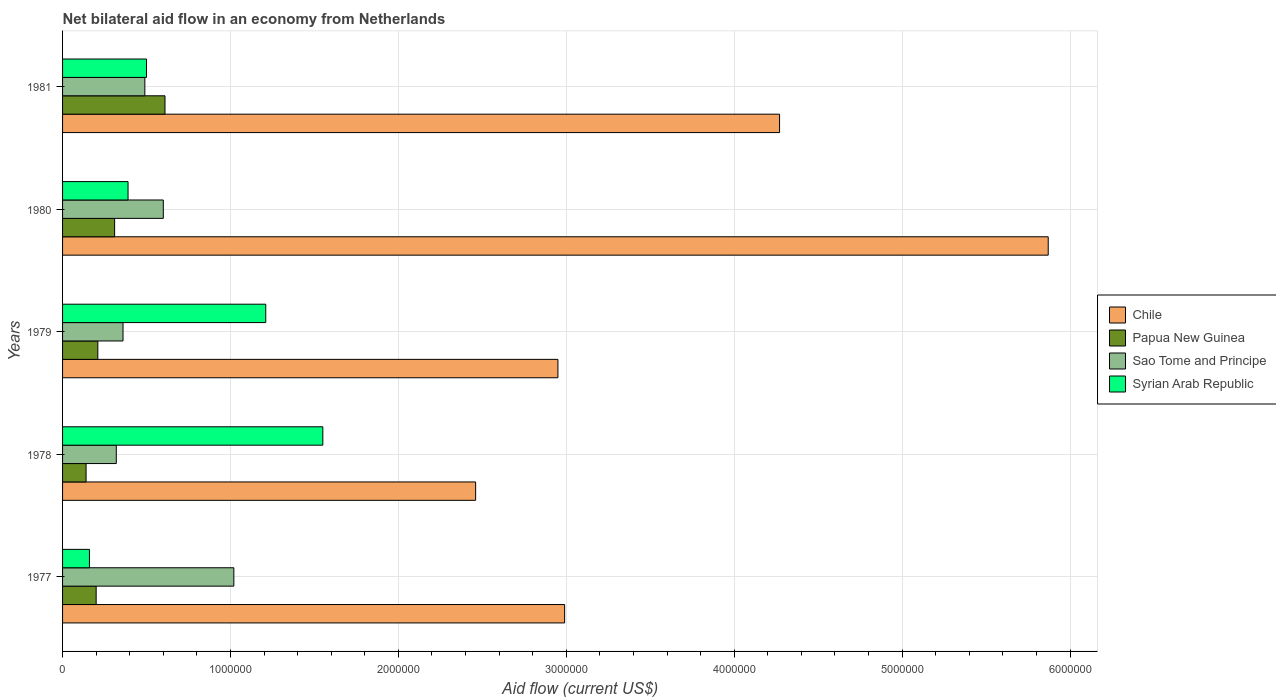Are the number of bars per tick equal to the number of legend labels?
Give a very brief answer. Yes. How many bars are there on the 2nd tick from the top?
Make the answer very short. 4. How many bars are there on the 4th tick from the bottom?
Your answer should be compact. 4. What is the label of the 3rd group of bars from the top?
Provide a short and direct response. 1979. In how many cases, is the number of bars for a given year not equal to the number of legend labels?
Your answer should be very brief. 0. Across all years, what is the maximum net bilateral aid flow in Sao Tome and Principe?
Provide a succinct answer. 1.02e+06. Across all years, what is the minimum net bilateral aid flow in Papua New Guinea?
Give a very brief answer. 1.40e+05. What is the total net bilateral aid flow in Chile in the graph?
Make the answer very short. 1.85e+07. What is the difference between the net bilateral aid flow in Sao Tome and Principe in 1979 and that in 1980?
Make the answer very short. -2.40e+05. What is the difference between the net bilateral aid flow in Syrian Arab Republic in 1981 and the net bilateral aid flow in Chile in 1977?
Your answer should be compact. -2.49e+06. What is the average net bilateral aid flow in Chile per year?
Provide a succinct answer. 3.71e+06. In the year 1979, what is the difference between the net bilateral aid flow in Syrian Arab Republic and net bilateral aid flow in Chile?
Provide a short and direct response. -1.74e+06. In how many years, is the net bilateral aid flow in Chile greater than 4000000 US$?
Your response must be concise. 2. What is the ratio of the net bilateral aid flow in Papua New Guinea in 1977 to that in 1978?
Offer a very short reply. 1.43. What is the difference between the highest and the lowest net bilateral aid flow in Syrian Arab Republic?
Provide a succinct answer. 1.39e+06. In how many years, is the net bilateral aid flow in Chile greater than the average net bilateral aid flow in Chile taken over all years?
Your response must be concise. 2. Is the sum of the net bilateral aid flow in Chile in 1977 and 1979 greater than the maximum net bilateral aid flow in Sao Tome and Principe across all years?
Offer a terse response. Yes. Is it the case that in every year, the sum of the net bilateral aid flow in Syrian Arab Republic and net bilateral aid flow in Chile is greater than the sum of net bilateral aid flow in Papua New Guinea and net bilateral aid flow in Sao Tome and Principe?
Provide a short and direct response. No. What does the 2nd bar from the top in 1977 represents?
Offer a very short reply. Sao Tome and Principe. What does the 2nd bar from the bottom in 1980 represents?
Provide a short and direct response. Papua New Guinea. How many bars are there?
Ensure brevity in your answer.  20. How many legend labels are there?
Provide a succinct answer. 4. What is the title of the graph?
Provide a short and direct response. Net bilateral aid flow in an economy from Netherlands. Does "United States" appear as one of the legend labels in the graph?
Provide a short and direct response. No. What is the label or title of the Y-axis?
Make the answer very short. Years. What is the Aid flow (current US$) of Chile in 1977?
Make the answer very short. 2.99e+06. What is the Aid flow (current US$) in Papua New Guinea in 1977?
Give a very brief answer. 2.00e+05. What is the Aid flow (current US$) of Sao Tome and Principe in 1977?
Give a very brief answer. 1.02e+06. What is the Aid flow (current US$) of Syrian Arab Republic in 1977?
Offer a terse response. 1.60e+05. What is the Aid flow (current US$) in Chile in 1978?
Provide a short and direct response. 2.46e+06. What is the Aid flow (current US$) of Papua New Guinea in 1978?
Give a very brief answer. 1.40e+05. What is the Aid flow (current US$) of Syrian Arab Republic in 1978?
Your response must be concise. 1.55e+06. What is the Aid flow (current US$) in Chile in 1979?
Provide a short and direct response. 2.95e+06. What is the Aid flow (current US$) of Syrian Arab Republic in 1979?
Keep it short and to the point. 1.21e+06. What is the Aid flow (current US$) in Chile in 1980?
Offer a terse response. 5.87e+06. What is the Aid flow (current US$) in Sao Tome and Principe in 1980?
Give a very brief answer. 6.00e+05. What is the Aid flow (current US$) in Syrian Arab Republic in 1980?
Offer a terse response. 3.90e+05. What is the Aid flow (current US$) in Chile in 1981?
Keep it short and to the point. 4.27e+06. What is the Aid flow (current US$) of Papua New Guinea in 1981?
Make the answer very short. 6.10e+05. Across all years, what is the maximum Aid flow (current US$) of Chile?
Offer a terse response. 5.87e+06. Across all years, what is the maximum Aid flow (current US$) in Sao Tome and Principe?
Your answer should be compact. 1.02e+06. Across all years, what is the maximum Aid flow (current US$) in Syrian Arab Republic?
Make the answer very short. 1.55e+06. Across all years, what is the minimum Aid flow (current US$) in Chile?
Provide a succinct answer. 2.46e+06. What is the total Aid flow (current US$) in Chile in the graph?
Your response must be concise. 1.85e+07. What is the total Aid flow (current US$) of Papua New Guinea in the graph?
Your answer should be very brief. 1.47e+06. What is the total Aid flow (current US$) of Sao Tome and Principe in the graph?
Provide a short and direct response. 2.79e+06. What is the total Aid flow (current US$) in Syrian Arab Republic in the graph?
Offer a terse response. 3.81e+06. What is the difference between the Aid flow (current US$) in Chile in 1977 and that in 1978?
Make the answer very short. 5.30e+05. What is the difference between the Aid flow (current US$) of Papua New Guinea in 1977 and that in 1978?
Provide a short and direct response. 6.00e+04. What is the difference between the Aid flow (current US$) of Sao Tome and Principe in 1977 and that in 1978?
Your answer should be compact. 7.00e+05. What is the difference between the Aid flow (current US$) of Syrian Arab Republic in 1977 and that in 1978?
Keep it short and to the point. -1.39e+06. What is the difference between the Aid flow (current US$) in Syrian Arab Republic in 1977 and that in 1979?
Provide a succinct answer. -1.05e+06. What is the difference between the Aid flow (current US$) of Chile in 1977 and that in 1980?
Ensure brevity in your answer.  -2.88e+06. What is the difference between the Aid flow (current US$) in Sao Tome and Principe in 1977 and that in 1980?
Offer a very short reply. 4.20e+05. What is the difference between the Aid flow (current US$) of Chile in 1977 and that in 1981?
Give a very brief answer. -1.28e+06. What is the difference between the Aid flow (current US$) in Papua New Guinea in 1977 and that in 1981?
Your response must be concise. -4.10e+05. What is the difference between the Aid flow (current US$) of Sao Tome and Principe in 1977 and that in 1981?
Ensure brevity in your answer.  5.30e+05. What is the difference between the Aid flow (current US$) of Chile in 1978 and that in 1979?
Offer a terse response. -4.90e+05. What is the difference between the Aid flow (current US$) in Papua New Guinea in 1978 and that in 1979?
Provide a short and direct response. -7.00e+04. What is the difference between the Aid flow (current US$) of Sao Tome and Principe in 1978 and that in 1979?
Give a very brief answer. -4.00e+04. What is the difference between the Aid flow (current US$) in Chile in 1978 and that in 1980?
Your answer should be very brief. -3.41e+06. What is the difference between the Aid flow (current US$) of Papua New Guinea in 1978 and that in 1980?
Provide a succinct answer. -1.70e+05. What is the difference between the Aid flow (current US$) of Sao Tome and Principe in 1978 and that in 1980?
Ensure brevity in your answer.  -2.80e+05. What is the difference between the Aid flow (current US$) in Syrian Arab Republic in 1978 and that in 1980?
Offer a terse response. 1.16e+06. What is the difference between the Aid flow (current US$) of Chile in 1978 and that in 1981?
Provide a succinct answer. -1.81e+06. What is the difference between the Aid flow (current US$) of Papua New Guinea in 1978 and that in 1981?
Keep it short and to the point. -4.70e+05. What is the difference between the Aid flow (current US$) of Syrian Arab Republic in 1978 and that in 1981?
Your answer should be compact. 1.05e+06. What is the difference between the Aid flow (current US$) in Chile in 1979 and that in 1980?
Offer a terse response. -2.92e+06. What is the difference between the Aid flow (current US$) of Papua New Guinea in 1979 and that in 1980?
Your answer should be very brief. -1.00e+05. What is the difference between the Aid flow (current US$) of Sao Tome and Principe in 1979 and that in 1980?
Your answer should be compact. -2.40e+05. What is the difference between the Aid flow (current US$) in Syrian Arab Republic in 1979 and that in 1980?
Make the answer very short. 8.20e+05. What is the difference between the Aid flow (current US$) of Chile in 1979 and that in 1981?
Your response must be concise. -1.32e+06. What is the difference between the Aid flow (current US$) in Papua New Guinea in 1979 and that in 1981?
Provide a succinct answer. -4.00e+05. What is the difference between the Aid flow (current US$) of Sao Tome and Principe in 1979 and that in 1981?
Your answer should be compact. -1.30e+05. What is the difference between the Aid flow (current US$) in Syrian Arab Republic in 1979 and that in 1981?
Provide a succinct answer. 7.10e+05. What is the difference between the Aid flow (current US$) of Chile in 1980 and that in 1981?
Make the answer very short. 1.60e+06. What is the difference between the Aid flow (current US$) in Chile in 1977 and the Aid flow (current US$) in Papua New Guinea in 1978?
Make the answer very short. 2.85e+06. What is the difference between the Aid flow (current US$) of Chile in 1977 and the Aid flow (current US$) of Sao Tome and Principe in 1978?
Your answer should be very brief. 2.67e+06. What is the difference between the Aid flow (current US$) of Chile in 1977 and the Aid flow (current US$) of Syrian Arab Republic in 1978?
Give a very brief answer. 1.44e+06. What is the difference between the Aid flow (current US$) of Papua New Guinea in 1977 and the Aid flow (current US$) of Syrian Arab Republic in 1978?
Offer a terse response. -1.35e+06. What is the difference between the Aid flow (current US$) of Sao Tome and Principe in 1977 and the Aid flow (current US$) of Syrian Arab Republic in 1978?
Keep it short and to the point. -5.30e+05. What is the difference between the Aid flow (current US$) in Chile in 1977 and the Aid flow (current US$) in Papua New Guinea in 1979?
Ensure brevity in your answer.  2.78e+06. What is the difference between the Aid flow (current US$) of Chile in 1977 and the Aid flow (current US$) of Sao Tome and Principe in 1979?
Give a very brief answer. 2.63e+06. What is the difference between the Aid flow (current US$) in Chile in 1977 and the Aid flow (current US$) in Syrian Arab Republic in 1979?
Make the answer very short. 1.78e+06. What is the difference between the Aid flow (current US$) of Papua New Guinea in 1977 and the Aid flow (current US$) of Sao Tome and Principe in 1979?
Make the answer very short. -1.60e+05. What is the difference between the Aid flow (current US$) of Papua New Guinea in 1977 and the Aid flow (current US$) of Syrian Arab Republic in 1979?
Ensure brevity in your answer.  -1.01e+06. What is the difference between the Aid flow (current US$) of Chile in 1977 and the Aid flow (current US$) of Papua New Guinea in 1980?
Offer a very short reply. 2.68e+06. What is the difference between the Aid flow (current US$) in Chile in 1977 and the Aid flow (current US$) in Sao Tome and Principe in 1980?
Your answer should be very brief. 2.39e+06. What is the difference between the Aid flow (current US$) in Chile in 1977 and the Aid flow (current US$) in Syrian Arab Republic in 1980?
Ensure brevity in your answer.  2.60e+06. What is the difference between the Aid flow (current US$) in Papua New Guinea in 1977 and the Aid flow (current US$) in Sao Tome and Principe in 1980?
Give a very brief answer. -4.00e+05. What is the difference between the Aid flow (current US$) of Papua New Guinea in 1977 and the Aid flow (current US$) of Syrian Arab Republic in 1980?
Your answer should be very brief. -1.90e+05. What is the difference between the Aid flow (current US$) in Sao Tome and Principe in 1977 and the Aid flow (current US$) in Syrian Arab Republic in 1980?
Keep it short and to the point. 6.30e+05. What is the difference between the Aid flow (current US$) in Chile in 1977 and the Aid flow (current US$) in Papua New Guinea in 1981?
Offer a terse response. 2.38e+06. What is the difference between the Aid flow (current US$) of Chile in 1977 and the Aid flow (current US$) of Sao Tome and Principe in 1981?
Your response must be concise. 2.50e+06. What is the difference between the Aid flow (current US$) of Chile in 1977 and the Aid flow (current US$) of Syrian Arab Republic in 1981?
Your response must be concise. 2.49e+06. What is the difference between the Aid flow (current US$) in Papua New Guinea in 1977 and the Aid flow (current US$) in Sao Tome and Principe in 1981?
Provide a short and direct response. -2.90e+05. What is the difference between the Aid flow (current US$) of Papua New Guinea in 1977 and the Aid flow (current US$) of Syrian Arab Republic in 1981?
Your response must be concise. -3.00e+05. What is the difference between the Aid flow (current US$) in Sao Tome and Principe in 1977 and the Aid flow (current US$) in Syrian Arab Republic in 1981?
Keep it short and to the point. 5.20e+05. What is the difference between the Aid flow (current US$) of Chile in 1978 and the Aid flow (current US$) of Papua New Guinea in 1979?
Provide a short and direct response. 2.25e+06. What is the difference between the Aid flow (current US$) in Chile in 1978 and the Aid flow (current US$) in Sao Tome and Principe in 1979?
Your response must be concise. 2.10e+06. What is the difference between the Aid flow (current US$) of Chile in 1978 and the Aid flow (current US$) of Syrian Arab Republic in 1979?
Your answer should be compact. 1.25e+06. What is the difference between the Aid flow (current US$) in Papua New Guinea in 1978 and the Aid flow (current US$) in Syrian Arab Republic in 1979?
Make the answer very short. -1.07e+06. What is the difference between the Aid flow (current US$) in Sao Tome and Principe in 1978 and the Aid flow (current US$) in Syrian Arab Republic in 1979?
Give a very brief answer. -8.90e+05. What is the difference between the Aid flow (current US$) in Chile in 1978 and the Aid flow (current US$) in Papua New Guinea in 1980?
Offer a terse response. 2.15e+06. What is the difference between the Aid flow (current US$) of Chile in 1978 and the Aid flow (current US$) of Sao Tome and Principe in 1980?
Provide a short and direct response. 1.86e+06. What is the difference between the Aid flow (current US$) in Chile in 1978 and the Aid flow (current US$) in Syrian Arab Republic in 1980?
Provide a succinct answer. 2.07e+06. What is the difference between the Aid flow (current US$) in Papua New Guinea in 1978 and the Aid flow (current US$) in Sao Tome and Principe in 1980?
Provide a short and direct response. -4.60e+05. What is the difference between the Aid flow (current US$) in Papua New Guinea in 1978 and the Aid flow (current US$) in Syrian Arab Republic in 1980?
Provide a succinct answer. -2.50e+05. What is the difference between the Aid flow (current US$) of Chile in 1978 and the Aid flow (current US$) of Papua New Guinea in 1981?
Provide a succinct answer. 1.85e+06. What is the difference between the Aid flow (current US$) in Chile in 1978 and the Aid flow (current US$) in Sao Tome and Principe in 1981?
Your answer should be compact. 1.97e+06. What is the difference between the Aid flow (current US$) of Chile in 1978 and the Aid flow (current US$) of Syrian Arab Republic in 1981?
Provide a short and direct response. 1.96e+06. What is the difference between the Aid flow (current US$) in Papua New Guinea in 1978 and the Aid flow (current US$) in Sao Tome and Principe in 1981?
Your response must be concise. -3.50e+05. What is the difference between the Aid flow (current US$) in Papua New Guinea in 1978 and the Aid flow (current US$) in Syrian Arab Republic in 1981?
Offer a very short reply. -3.60e+05. What is the difference between the Aid flow (current US$) of Chile in 1979 and the Aid flow (current US$) of Papua New Guinea in 1980?
Your answer should be very brief. 2.64e+06. What is the difference between the Aid flow (current US$) of Chile in 1979 and the Aid flow (current US$) of Sao Tome and Principe in 1980?
Offer a terse response. 2.35e+06. What is the difference between the Aid flow (current US$) of Chile in 1979 and the Aid flow (current US$) of Syrian Arab Republic in 1980?
Your response must be concise. 2.56e+06. What is the difference between the Aid flow (current US$) of Papua New Guinea in 1979 and the Aid flow (current US$) of Sao Tome and Principe in 1980?
Your answer should be compact. -3.90e+05. What is the difference between the Aid flow (current US$) in Papua New Guinea in 1979 and the Aid flow (current US$) in Syrian Arab Republic in 1980?
Offer a terse response. -1.80e+05. What is the difference between the Aid flow (current US$) of Sao Tome and Principe in 1979 and the Aid flow (current US$) of Syrian Arab Republic in 1980?
Make the answer very short. -3.00e+04. What is the difference between the Aid flow (current US$) of Chile in 1979 and the Aid flow (current US$) of Papua New Guinea in 1981?
Keep it short and to the point. 2.34e+06. What is the difference between the Aid flow (current US$) in Chile in 1979 and the Aid flow (current US$) in Sao Tome and Principe in 1981?
Your response must be concise. 2.46e+06. What is the difference between the Aid flow (current US$) of Chile in 1979 and the Aid flow (current US$) of Syrian Arab Republic in 1981?
Make the answer very short. 2.45e+06. What is the difference between the Aid flow (current US$) in Papua New Guinea in 1979 and the Aid flow (current US$) in Sao Tome and Principe in 1981?
Your response must be concise. -2.80e+05. What is the difference between the Aid flow (current US$) in Chile in 1980 and the Aid flow (current US$) in Papua New Guinea in 1981?
Your answer should be compact. 5.26e+06. What is the difference between the Aid flow (current US$) in Chile in 1980 and the Aid flow (current US$) in Sao Tome and Principe in 1981?
Provide a short and direct response. 5.38e+06. What is the difference between the Aid flow (current US$) of Chile in 1980 and the Aid flow (current US$) of Syrian Arab Republic in 1981?
Ensure brevity in your answer.  5.37e+06. What is the difference between the Aid flow (current US$) of Papua New Guinea in 1980 and the Aid flow (current US$) of Syrian Arab Republic in 1981?
Your answer should be very brief. -1.90e+05. What is the difference between the Aid flow (current US$) of Sao Tome and Principe in 1980 and the Aid flow (current US$) of Syrian Arab Republic in 1981?
Your answer should be very brief. 1.00e+05. What is the average Aid flow (current US$) of Chile per year?
Offer a very short reply. 3.71e+06. What is the average Aid flow (current US$) in Papua New Guinea per year?
Offer a terse response. 2.94e+05. What is the average Aid flow (current US$) of Sao Tome and Principe per year?
Make the answer very short. 5.58e+05. What is the average Aid flow (current US$) in Syrian Arab Republic per year?
Give a very brief answer. 7.62e+05. In the year 1977, what is the difference between the Aid flow (current US$) of Chile and Aid flow (current US$) of Papua New Guinea?
Offer a terse response. 2.79e+06. In the year 1977, what is the difference between the Aid flow (current US$) of Chile and Aid flow (current US$) of Sao Tome and Principe?
Keep it short and to the point. 1.97e+06. In the year 1977, what is the difference between the Aid flow (current US$) of Chile and Aid flow (current US$) of Syrian Arab Republic?
Make the answer very short. 2.83e+06. In the year 1977, what is the difference between the Aid flow (current US$) in Papua New Guinea and Aid flow (current US$) in Sao Tome and Principe?
Provide a short and direct response. -8.20e+05. In the year 1977, what is the difference between the Aid flow (current US$) in Papua New Guinea and Aid flow (current US$) in Syrian Arab Republic?
Offer a terse response. 4.00e+04. In the year 1977, what is the difference between the Aid flow (current US$) of Sao Tome and Principe and Aid flow (current US$) of Syrian Arab Republic?
Provide a short and direct response. 8.60e+05. In the year 1978, what is the difference between the Aid flow (current US$) of Chile and Aid flow (current US$) of Papua New Guinea?
Keep it short and to the point. 2.32e+06. In the year 1978, what is the difference between the Aid flow (current US$) of Chile and Aid flow (current US$) of Sao Tome and Principe?
Ensure brevity in your answer.  2.14e+06. In the year 1978, what is the difference between the Aid flow (current US$) of Chile and Aid flow (current US$) of Syrian Arab Republic?
Provide a succinct answer. 9.10e+05. In the year 1978, what is the difference between the Aid flow (current US$) in Papua New Guinea and Aid flow (current US$) in Sao Tome and Principe?
Your answer should be compact. -1.80e+05. In the year 1978, what is the difference between the Aid flow (current US$) of Papua New Guinea and Aid flow (current US$) of Syrian Arab Republic?
Offer a terse response. -1.41e+06. In the year 1978, what is the difference between the Aid flow (current US$) of Sao Tome and Principe and Aid flow (current US$) of Syrian Arab Republic?
Offer a very short reply. -1.23e+06. In the year 1979, what is the difference between the Aid flow (current US$) in Chile and Aid flow (current US$) in Papua New Guinea?
Provide a short and direct response. 2.74e+06. In the year 1979, what is the difference between the Aid flow (current US$) in Chile and Aid flow (current US$) in Sao Tome and Principe?
Make the answer very short. 2.59e+06. In the year 1979, what is the difference between the Aid flow (current US$) of Chile and Aid flow (current US$) of Syrian Arab Republic?
Your response must be concise. 1.74e+06. In the year 1979, what is the difference between the Aid flow (current US$) in Papua New Guinea and Aid flow (current US$) in Sao Tome and Principe?
Ensure brevity in your answer.  -1.50e+05. In the year 1979, what is the difference between the Aid flow (current US$) in Sao Tome and Principe and Aid flow (current US$) in Syrian Arab Republic?
Provide a succinct answer. -8.50e+05. In the year 1980, what is the difference between the Aid flow (current US$) in Chile and Aid flow (current US$) in Papua New Guinea?
Your answer should be very brief. 5.56e+06. In the year 1980, what is the difference between the Aid flow (current US$) in Chile and Aid flow (current US$) in Sao Tome and Principe?
Your answer should be very brief. 5.27e+06. In the year 1980, what is the difference between the Aid flow (current US$) of Chile and Aid flow (current US$) of Syrian Arab Republic?
Your response must be concise. 5.48e+06. In the year 1980, what is the difference between the Aid flow (current US$) in Sao Tome and Principe and Aid flow (current US$) in Syrian Arab Republic?
Offer a very short reply. 2.10e+05. In the year 1981, what is the difference between the Aid flow (current US$) in Chile and Aid flow (current US$) in Papua New Guinea?
Provide a succinct answer. 3.66e+06. In the year 1981, what is the difference between the Aid flow (current US$) in Chile and Aid flow (current US$) in Sao Tome and Principe?
Offer a terse response. 3.78e+06. In the year 1981, what is the difference between the Aid flow (current US$) in Chile and Aid flow (current US$) in Syrian Arab Republic?
Keep it short and to the point. 3.77e+06. In the year 1981, what is the difference between the Aid flow (current US$) of Papua New Guinea and Aid flow (current US$) of Syrian Arab Republic?
Provide a succinct answer. 1.10e+05. What is the ratio of the Aid flow (current US$) in Chile in 1977 to that in 1978?
Offer a very short reply. 1.22. What is the ratio of the Aid flow (current US$) of Papua New Guinea in 1977 to that in 1978?
Your response must be concise. 1.43. What is the ratio of the Aid flow (current US$) in Sao Tome and Principe in 1977 to that in 1978?
Provide a succinct answer. 3.19. What is the ratio of the Aid flow (current US$) of Syrian Arab Republic in 1977 to that in 1978?
Give a very brief answer. 0.1. What is the ratio of the Aid flow (current US$) in Chile in 1977 to that in 1979?
Offer a very short reply. 1.01. What is the ratio of the Aid flow (current US$) in Sao Tome and Principe in 1977 to that in 1979?
Ensure brevity in your answer.  2.83. What is the ratio of the Aid flow (current US$) of Syrian Arab Republic in 1977 to that in 1979?
Ensure brevity in your answer.  0.13. What is the ratio of the Aid flow (current US$) in Chile in 1977 to that in 1980?
Ensure brevity in your answer.  0.51. What is the ratio of the Aid flow (current US$) of Papua New Guinea in 1977 to that in 1980?
Your response must be concise. 0.65. What is the ratio of the Aid flow (current US$) in Syrian Arab Republic in 1977 to that in 1980?
Give a very brief answer. 0.41. What is the ratio of the Aid flow (current US$) in Chile in 1977 to that in 1981?
Your response must be concise. 0.7. What is the ratio of the Aid flow (current US$) in Papua New Guinea in 1977 to that in 1981?
Your response must be concise. 0.33. What is the ratio of the Aid flow (current US$) in Sao Tome and Principe in 1977 to that in 1981?
Ensure brevity in your answer.  2.08. What is the ratio of the Aid flow (current US$) in Syrian Arab Republic in 1977 to that in 1981?
Provide a succinct answer. 0.32. What is the ratio of the Aid flow (current US$) of Chile in 1978 to that in 1979?
Provide a short and direct response. 0.83. What is the ratio of the Aid flow (current US$) in Papua New Guinea in 1978 to that in 1979?
Your answer should be compact. 0.67. What is the ratio of the Aid flow (current US$) in Sao Tome and Principe in 1978 to that in 1979?
Offer a very short reply. 0.89. What is the ratio of the Aid flow (current US$) of Syrian Arab Republic in 1978 to that in 1979?
Your response must be concise. 1.28. What is the ratio of the Aid flow (current US$) in Chile in 1978 to that in 1980?
Provide a short and direct response. 0.42. What is the ratio of the Aid flow (current US$) in Papua New Guinea in 1978 to that in 1980?
Give a very brief answer. 0.45. What is the ratio of the Aid flow (current US$) of Sao Tome and Principe in 1978 to that in 1980?
Keep it short and to the point. 0.53. What is the ratio of the Aid flow (current US$) in Syrian Arab Republic in 1978 to that in 1980?
Provide a short and direct response. 3.97. What is the ratio of the Aid flow (current US$) of Chile in 1978 to that in 1981?
Provide a succinct answer. 0.58. What is the ratio of the Aid flow (current US$) in Papua New Guinea in 1978 to that in 1981?
Provide a short and direct response. 0.23. What is the ratio of the Aid flow (current US$) of Sao Tome and Principe in 1978 to that in 1981?
Offer a very short reply. 0.65. What is the ratio of the Aid flow (current US$) of Chile in 1979 to that in 1980?
Your answer should be compact. 0.5. What is the ratio of the Aid flow (current US$) of Papua New Guinea in 1979 to that in 1980?
Make the answer very short. 0.68. What is the ratio of the Aid flow (current US$) of Sao Tome and Principe in 1979 to that in 1980?
Provide a succinct answer. 0.6. What is the ratio of the Aid flow (current US$) in Syrian Arab Republic in 1979 to that in 1980?
Give a very brief answer. 3.1. What is the ratio of the Aid flow (current US$) of Chile in 1979 to that in 1981?
Your answer should be very brief. 0.69. What is the ratio of the Aid flow (current US$) of Papua New Guinea in 1979 to that in 1981?
Provide a short and direct response. 0.34. What is the ratio of the Aid flow (current US$) of Sao Tome and Principe in 1979 to that in 1981?
Keep it short and to the point. 0.73. What is the ratio of the Aid flow (current US$) in Syrian Arab Republic in 1979 to that in 1981?
Ensure brevity in your answer.  2.42. What is the ratio of the Aid flow (current US$) in Chile in 1980 to that in 1981?
Your response must be concise. 1.37. What is the ratio of the Aid flow (current US$) of Papua New Guinea in 1980 to that in 1981?
Give a very brief answer. 0.51. What is the ratio of the Aid flow (current US$) in Sao Tome and Principe in 1980 to that in 1981?
Make the answer very short. 1.22. What is the ratio of the Aid flow (current US$) of Syrian Arab Republic in 1980 to that in 1981?
Give a very brief answer. 0.78. What is the difference between the highest and the second highest Aid flow (current US$) in Chile?
Keep it short and to the point. 1.60e+06. What is the difference between the highest and the second highest Aid flow (current US$) of Papua New Guinea?
Give a very brief answer. 3.00e+05. What is the difference between the highest and the second highest Aid flow (current US$) in Sao Tome and Principe?
Keep it short and to the point. 4.20e+05. What is the difference between the highest and the lowest Aid flow (current US$) in Chile?
Your answer should be compact. 3.41e+06. What is the difference between the highest and the lowest Aid flow (current US$) of Papua New Guinea?
Offer a very short reply. 4.70e+05. What is the difference between the highest and the lowest Aid flow (current US$) of Syrian Arab Republic?
Offer a very short reply. 1.39e+06. 